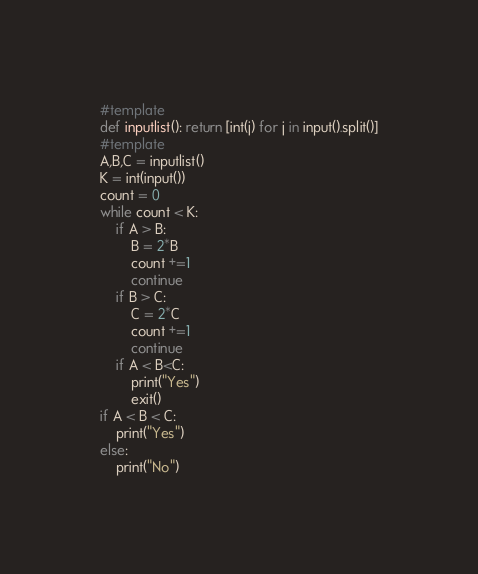<code> <loc_0><loc_0><loc_500><loc_500><_Python_>#template
def inputlist(): return [int(j) for j in input().split()]
#template
A,B,C = inputlist()
K = int(input())
count = 0
while count < K:
    if A > B:
        B = 2*B
        count +=1
        continue
    if B > C:
        C = 2*C
        count +=1
        continue
    if A < B<C:
        print("Yes")
        exit()
if A < B < C:
    print("Yes")
else:
    print("No")</code> 